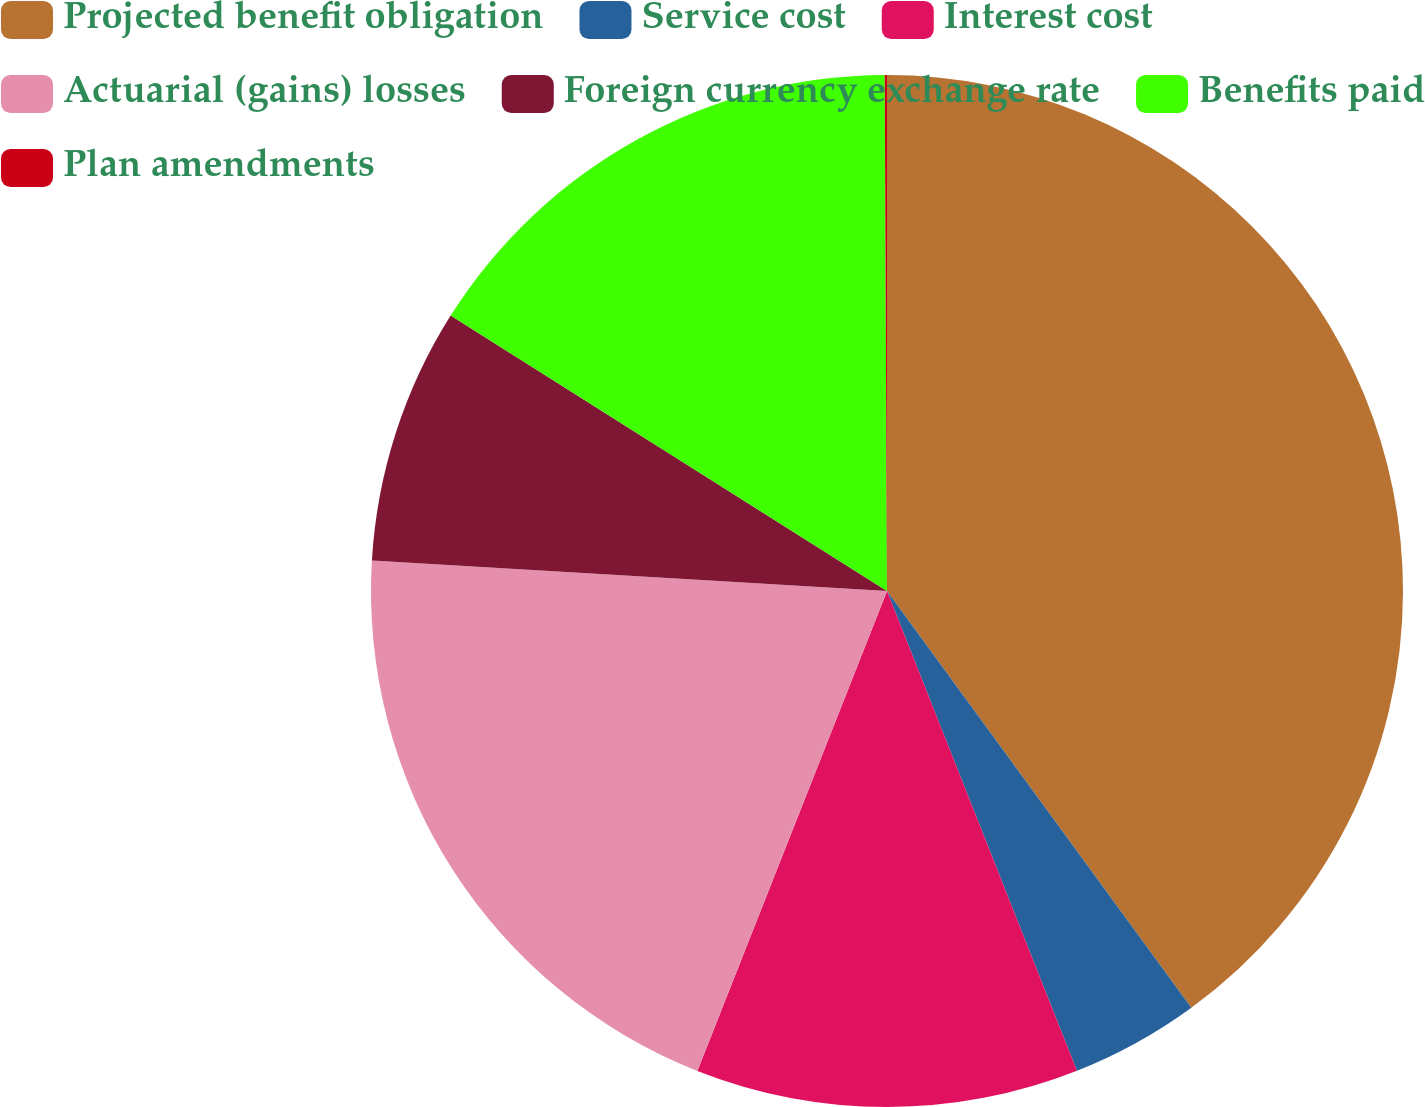<chart> <loc_0><loc_0><loc_500><loc_500><pie_chart><fcel>Projected benefit obligation<fcel>Service cost<fcel>Interest cost<fcel>Actuarial (gains) losses<fcel>Foreign currency exchange rate<fcel>Benefits paid<fcel>Plan amendments<nl><fcel>39.96%<fcel>4.04%<fcel>11.99%<fcel>19.95%<fcel>8.02%<fcel>15.97%<fcel>0.07%<nl></chart> 